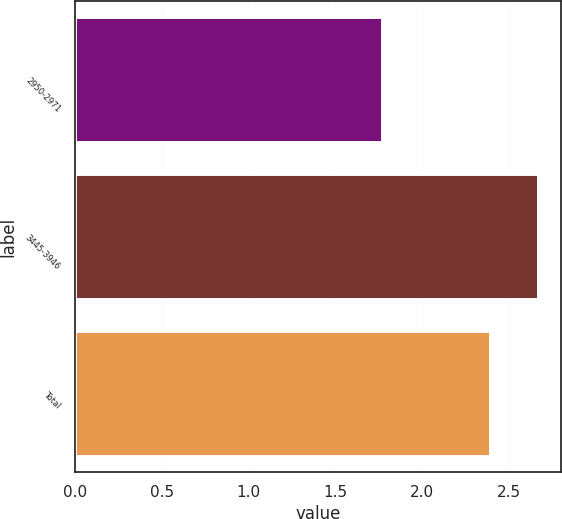Convert chart to OTSL. <chart><loc_0><loc_0><loc_500><loc_500><bar_chart><fcel>2950-2971<fcel>3445-3946<fcel>Total<nl><fcel>1.77<fcel>2.67<fcel>2.39<nl></chart> 